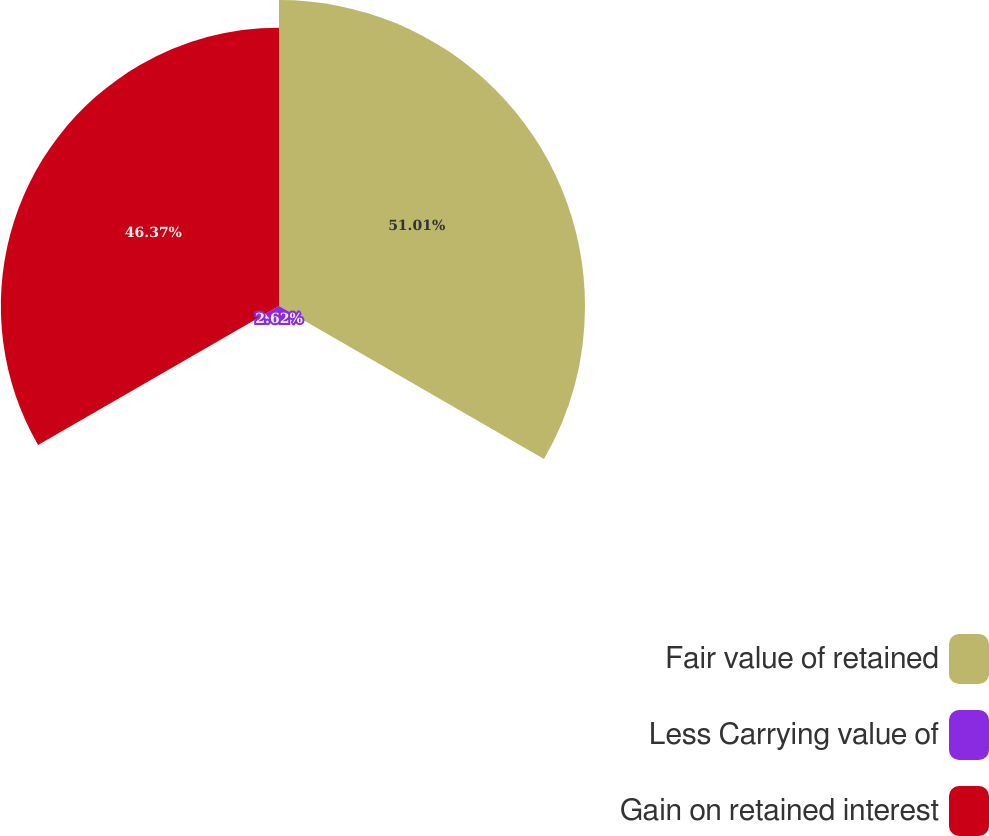Convert chart to OTSL. <chart><loc_0><loc_0><loc_500><loc_500><pie_chart><fcel>Fair value of retained<fcel>Less Carrying value of<fcel>Gain on retained interest<nl><fcel>51.01%<fcel>2.62%<fcel>46.37%<nl></chart> 